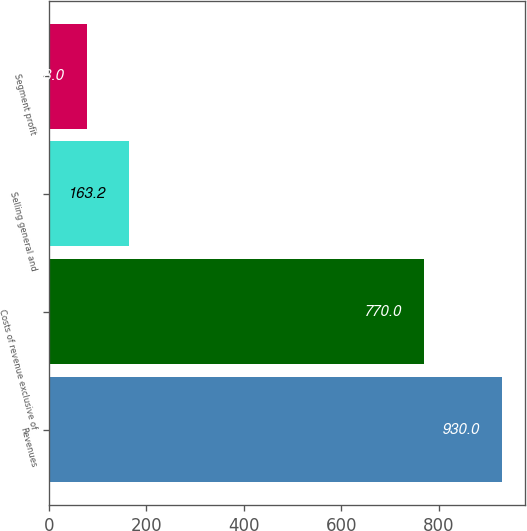Convert chart. <chart><loc_0><loc_0><loc_500><loc_500><bar_chart><fcel>Revenues<fcel>Costs of revenue exclusive of<fcel>Selling general and<fcel>Segment profit<nl><fcel>930<fcel>770<fcel>163.2<fcel>78<nl></chart> 